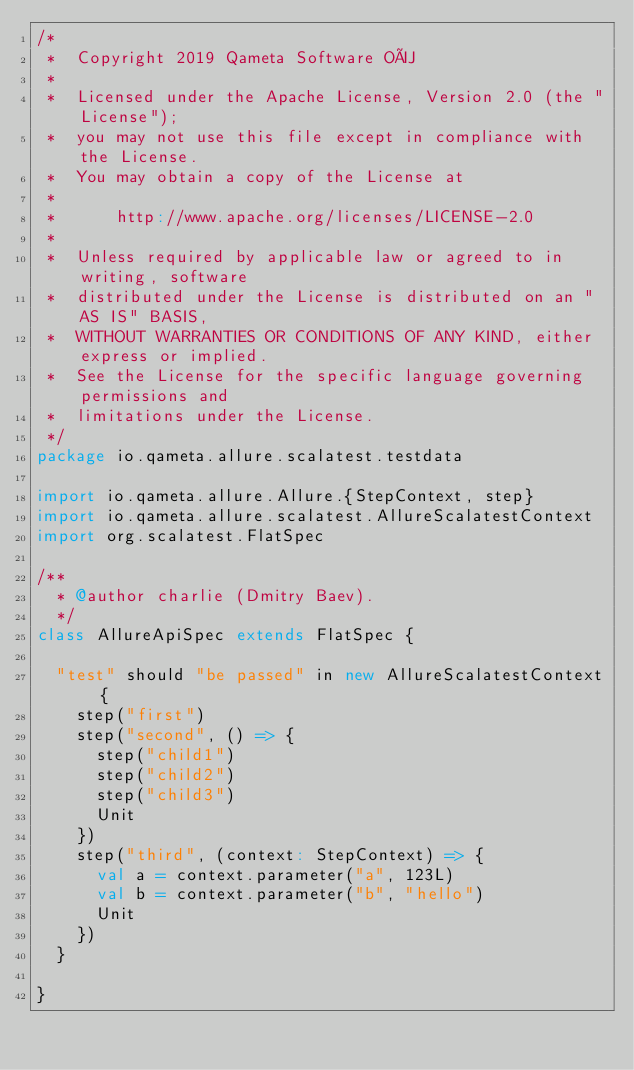<code> <loc_0><loc_0><loc_500><loc_500><_Scala_>/*
 *  Copyright 2019 Qameta Software OÜ
 *
 *  Licensed under the Apache License, Version 2.0 (the "License");
 *  you may not use this file except in compliance with the License.
 *  You may obtain a copy of the License at
 *
 *      http://www.apache.org/licenses/LICENSE-2.0
 *
 *  Unless required by applicable law or agreed to in writing, software
 *  distributed under the License is distributed on an "AS IS" BASIS,
 *  WITHOUT WARRANTIES OR CONDITIONS OF ANY KIND, either express or implied.
 *  See the License for the specific language governing permissions and
 *  limitations under the License.
 */
package io.qameta.allure.scalatest.testdata

import io.qameta.allure.Allure.{StepContext, step}
import io.qameta.allure.scalatest.AllureScalatestContext
import org.scalatest.FlatSpec

/**
  * @author charlie (Dmitry Baev).
  */
class AllureApiSpec extends FlatSpec {

  "test" should "be passed" in new AllureScalatestContext {
    step("first")
    step("second", () => {
      step("child1")
      step("child2")
      step("child3")
      Unit
    })
    step("third", (context: StepContext) => {
      val a = context.parameter("a", 123L)
      val b = context.parameter("b", "hello")
      Unit
    })
  }

}
</code> 